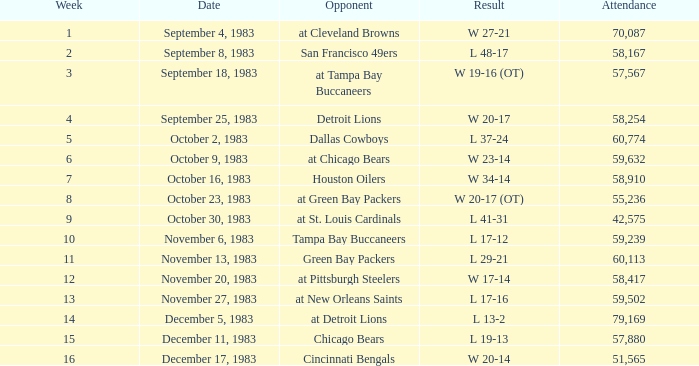What happened on November 20, 1983 before week 15? W 17-14. 